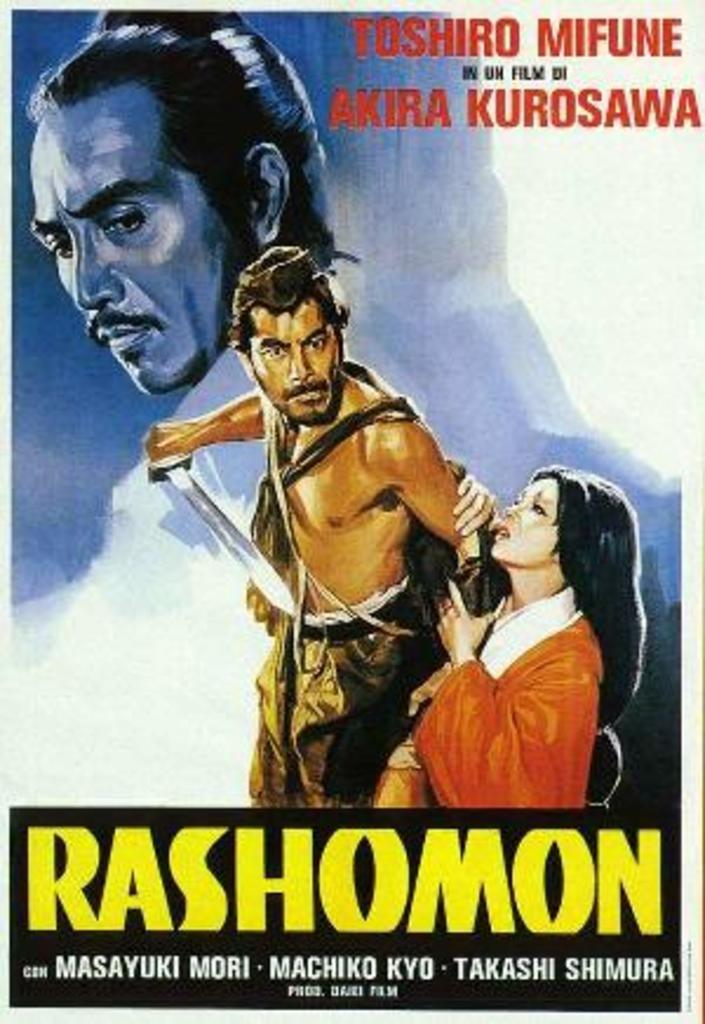<image>
Summarize the visual content of the image. A poster featuring a man with a sword and a woman in an orange dress with the caption 'Rashomon'. 